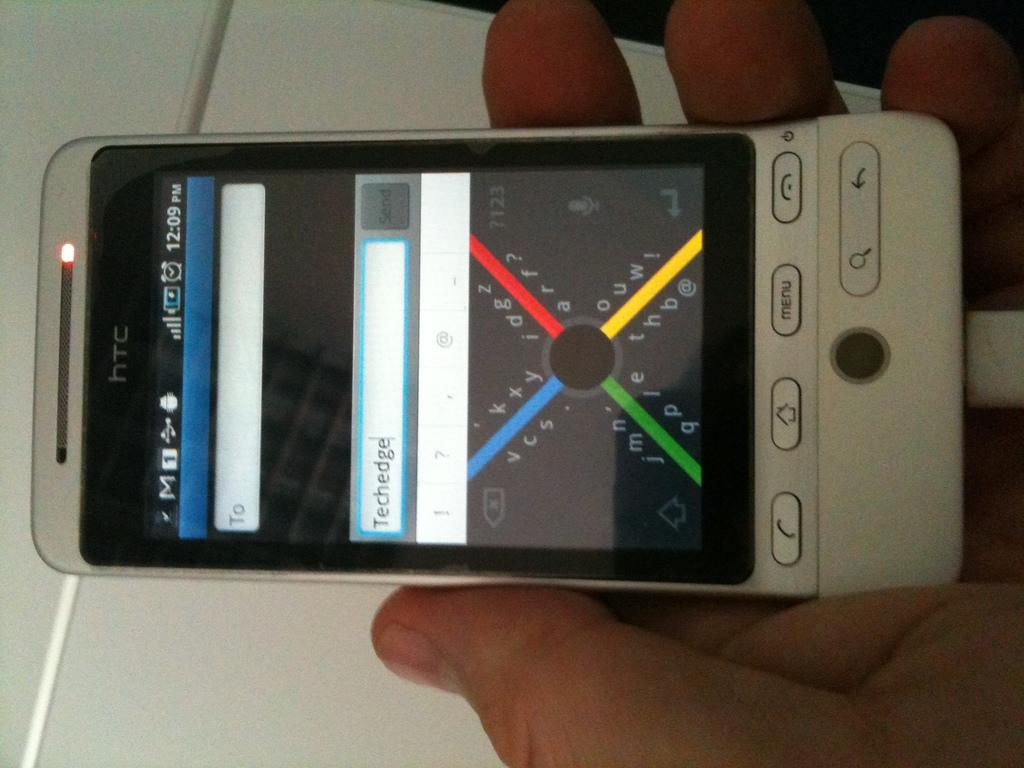<image>
Offer a succinct explanation of the picture presented. An HTC phone screen displays the word "techedge" in a text box. 